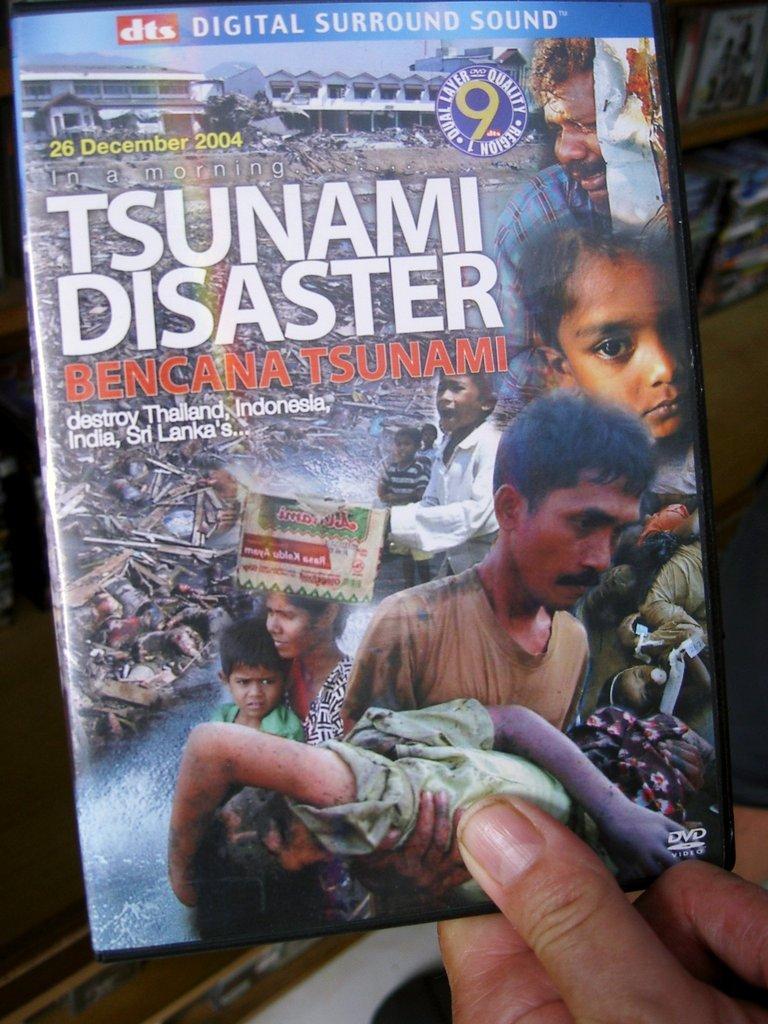In one or two sentences, can you explain what this image depicts? In this image we can see a person's hand holding a compact disc. 